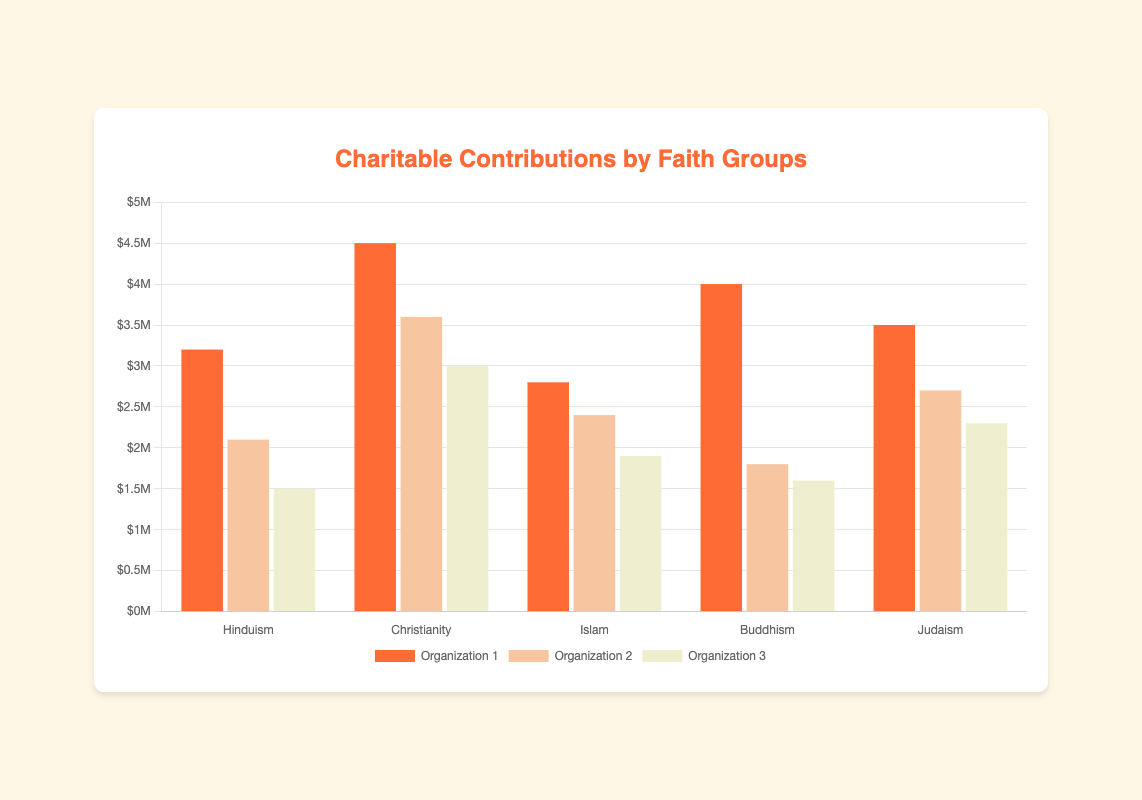What is the total amount donated by Hindu organizations? To find the total, add up the amounts donated by ISKCON Food Relief Foundation, Ramakrishna Mission, and Sewa International: 3200000 + 2100000 + 1500000 = 6800000.
Answer: 6800000 Which faith group's organization donated the most in health care? We look at the "Health Care" donations: World Vision (3600000) for Christianity and Jewish Federations of North America (2700000) for Judaism. World Vision has the highest donation.
Answer: Christianity Which organization has made the highest donation for disaster relief? We examine the "Disaster Relief" donations: Sewa International (1500000) for Hinduism, Islamic Relief Worldwide (2800000) for Islam, and Tzu Chi Foundation (4000000) for Buddhism. Tzu Chi Foundation has the highest donation.
Answer: Tzu Chi Foundation Compare the total donations from Buddhism and Christianity. Which is greater and by how much? Sum up the donations for each faith group: Buddhism (4000000 + 1800000 + 1600000 = 7400000) and Christianity (4500000 + 3600000 + 3000000 = 11100000). 11100000 (Christianity) - 7400000 (Buddhism) = 3700000.
Answer: Christianity, by 3700000 Which faith group has the least total donation? Calculate the total donation for each faith group: Hinduism (6800000), Christianity (11100000), Islam (7100000), Buddhism (7400000), Judaism (8500000). The smallest is Hinduism.
Answer: Hinduism What is the average donation amount of organizations under Islam? Sum the donations and divide by the number of organizations: (2800000 + 2400000 + 1900000) / 3 = 7100000 / 3 = 2366666.67.
Answer: 2366666.67 Which organization's donation is closest to 3 million dollars? Compare the amounts donated by all organizations to 3000000: Salvation Army (3000000) from Christianity matches exactly.
Answer: Salvation Army What is the combined donation for food and nutrition across all faith groups? Add the donations for food and nutrition: ISKCON Food Relief Foundation (3200000), Buddhist Global Relief (1800000), and MAZON (2300000): 3200000 + 1800000 + 2300000 = 7300000.
Answer: 7300000 What is the difference in donations between Catholic Charities and Islamic Relief Worldwide? Subtract the donation amount of Islamic Relief Worldwide from Catholic Charities: 4500000 - 2800000 = 1700000.
Answer: 1700000 Which area of support received the highest combined donation across all groups? Sum donations for each area: food and nutrition (3200000 + 1800000 + 2300000 = 7300000), education (2100000 + 1900000 + 1600000 = 5600000), disaster relief (1500000 + 2800000 + 4000000 = 8300000), poverty alleviation (4500000 + 2400000 + 3500000 = 10400000), health care (3600000 + 2700000 = 6300000), homelessness (3000000). Poverty alleviation has the highest sum of 10400000.
Answer: Poverty alleviation 